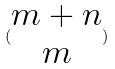Convert formula to latex. <formula><loc_0><loc_0><loc_500><loc_500>( \begin{matrix} m + n \\ m \end{matrix} )</formula> 